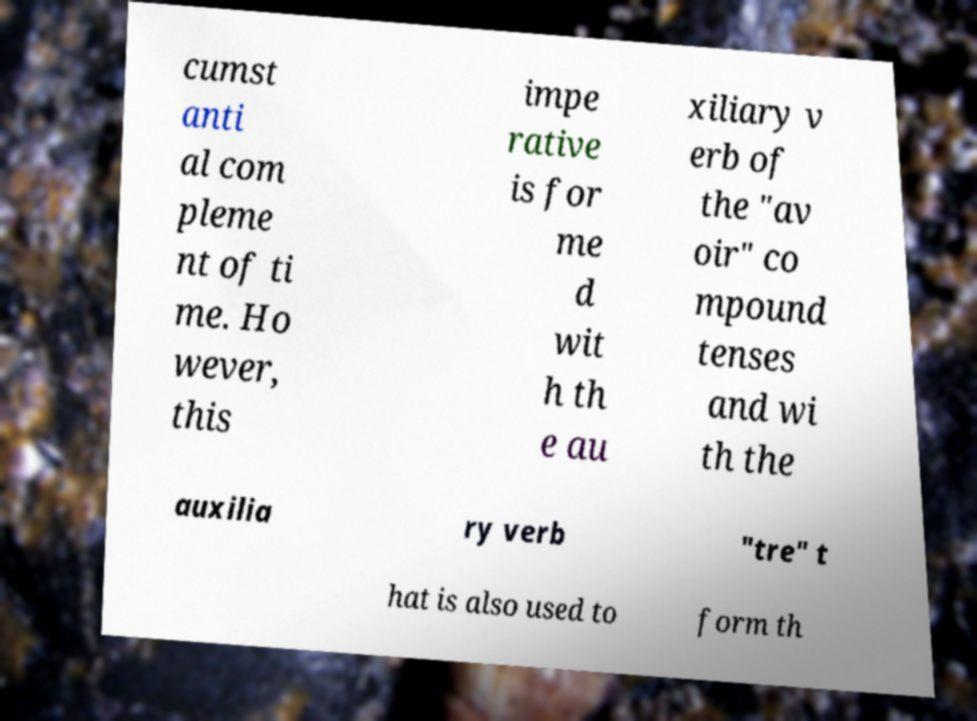Can you accurately transcribe the text from the provided image for me? cumst anti al com pleme nt of ti me. Ho wever, this impe rative is for me d wit h th e au xiliary v erb of the "av oir" co mpound tenses and wi th the auxilia ry verb "tre" t hat is also used to form th 